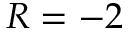<formula> <loc_0><loc_0><loc_500><loc_500>R = - 2</formula> 